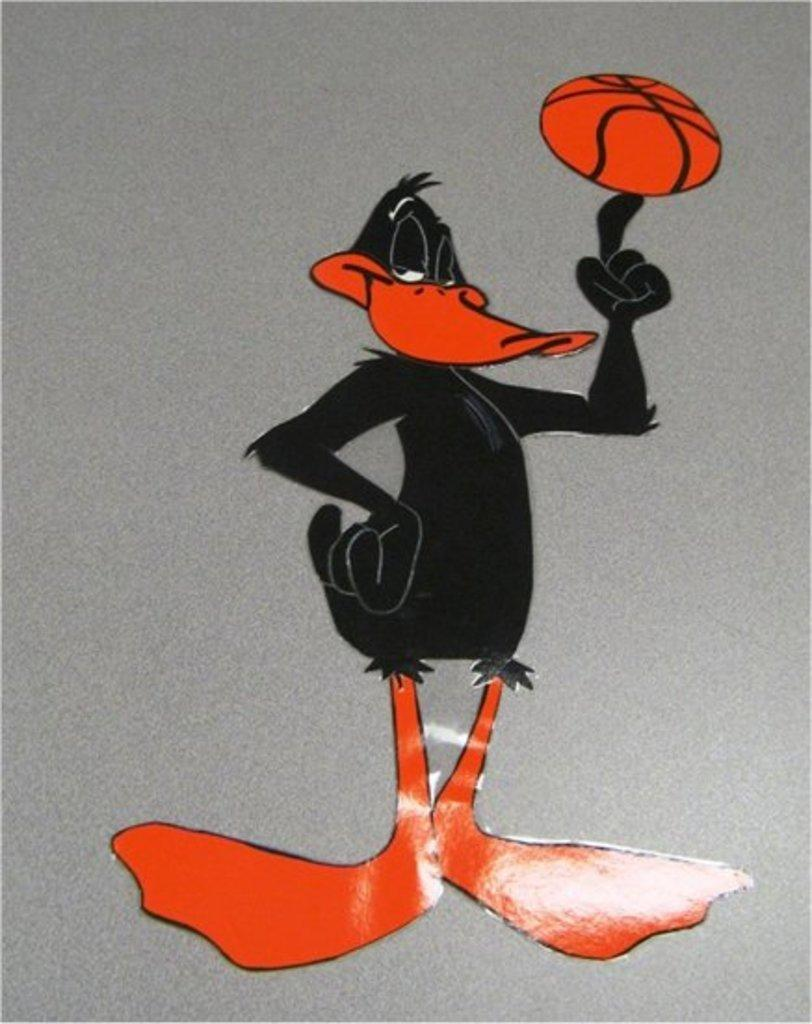What colors are used in the cartoon in the image? The cartoon in the image is black and orange in color. What type of dirt can be seen in the image? There is no dirt present in the image; it features a black and orange cartoon. What is the title of the cartoon in the image? The provided facts do not mention a title for the cartoon in the image. What type of property does the cartoon character own in the image? The provided facts do not mention any property owned by the cartoon character in the image. 